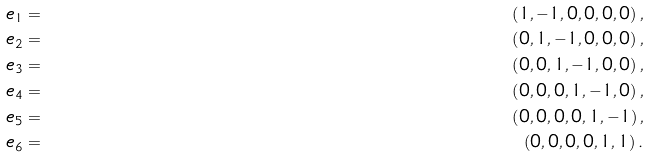Convert formula to latex. <formula><loc_0><loc_0><loc_500><loc_500>e _ { 1 } & = & \left ( 1 , - 1 , 0 , 0 , 0 , 0 \right ) , \\ e _ { 2 } & = & \left ( 0 , 1 , - 1 , 0 , 0 , 0 \right ) , \\ e _ { 3 } & = & \left ( 0 , 0 , 1 , - 1 , 0 , 0 \right ) , \\ e _ { 4 } & = & \left ( 0 , 0 , 0 , 1 , - 1 , 0 \right ) , \\ e _ { 5 } & = & \left ( 0 , 0 , 0 , 0 , 1 , - 1 \right ) , \\ e _ { 6 } & = & \left ( 0 , 0 , 0 , 0 , 1 , 1 \right ) .</formula> 